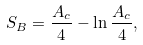Convert formula to latex. <formula><loc_0><loc_0><loc_500><loc_500>S _ { B } = \frac { A _ { c } } { 4 } - \ln \frac { A _ { c } } { 4 } ,</formula> 